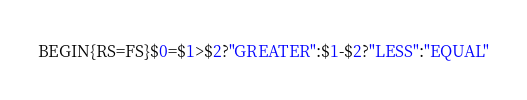Convert code to text. <code><loc_0><loc_0><loc_500><loc_500><_Awk_>BEGIN{RS=FS}$0=$1>$2?"GREATER":$1-$2?"LESS":"EQUAL"</code> 